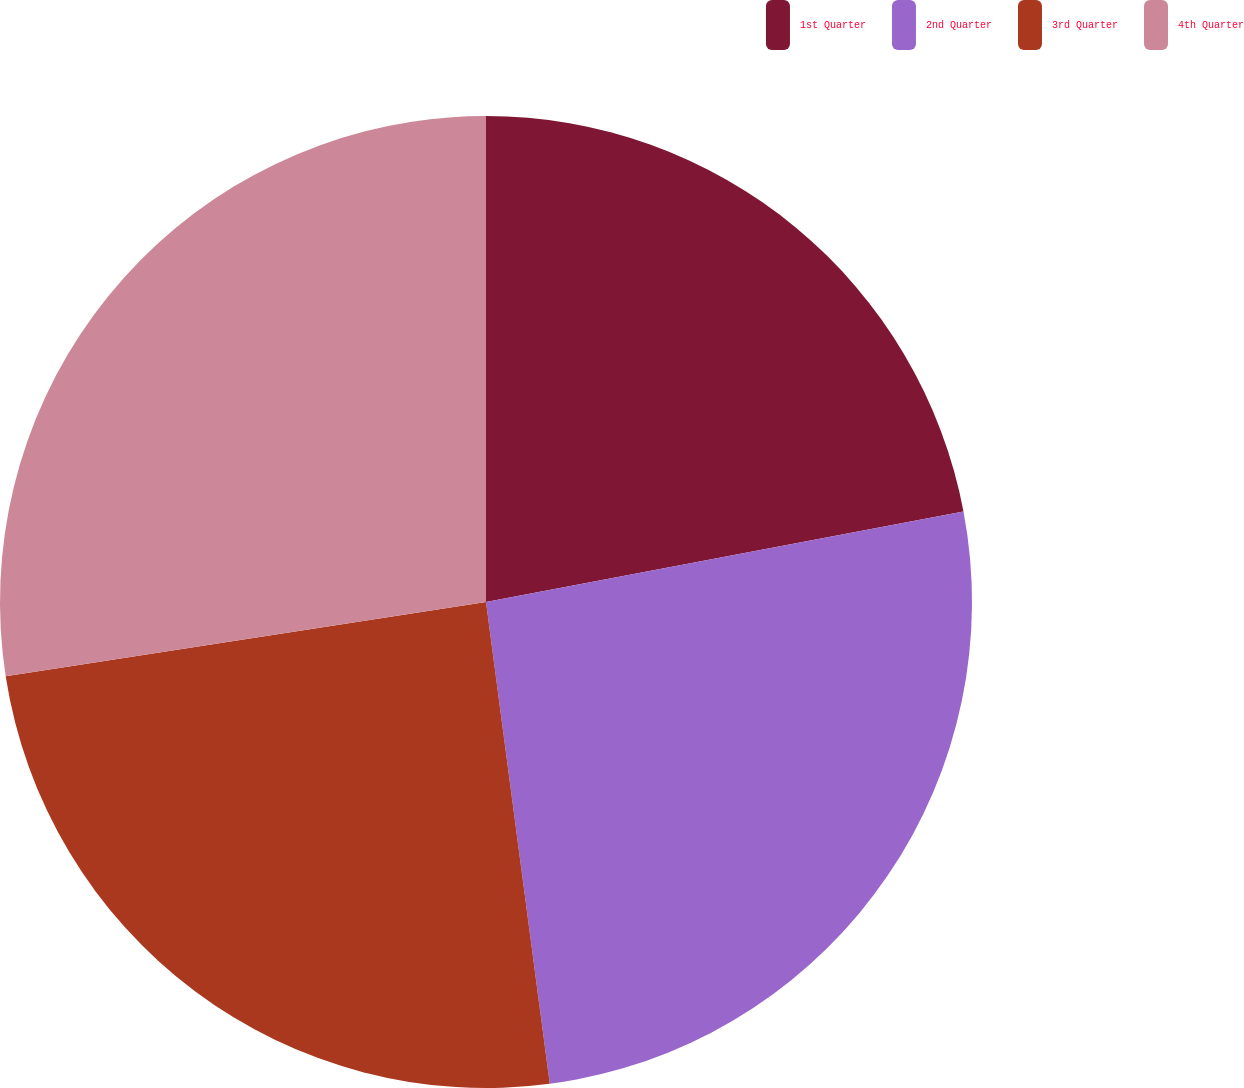<chart> <loc_0><loc_0><loc_500><loc_500><pie_chart><fcel>1st Quarter<fcel>2nd Quarter<fcel>3rd Quarter<fcel>4th Quarter<nl><fcel>22.02%<fcel>25.89%<fcel>24.66%<fcel>27.44%<nl></chart> 